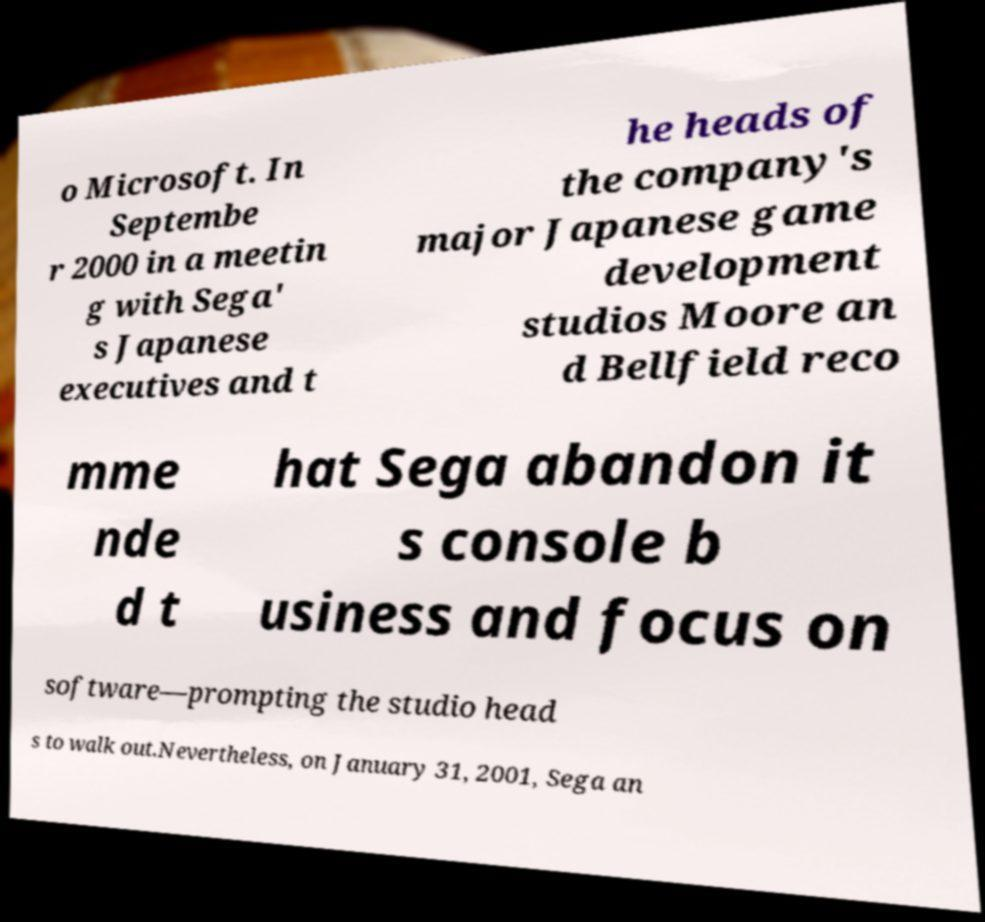I need the written content from this picture converted into text. Can you do that? o Microsoft. In Septembe r 2000 in a meetin g with Sega' s Japanese executives and t he heads of the company's major Japanese game development studios Moore an d Bellfield reco mme nde d t hat Sega abandon it s console b usiness and focus on software—prompting the studio head s to walk out.Nevertheless, on January 31, 2001, Sega an 